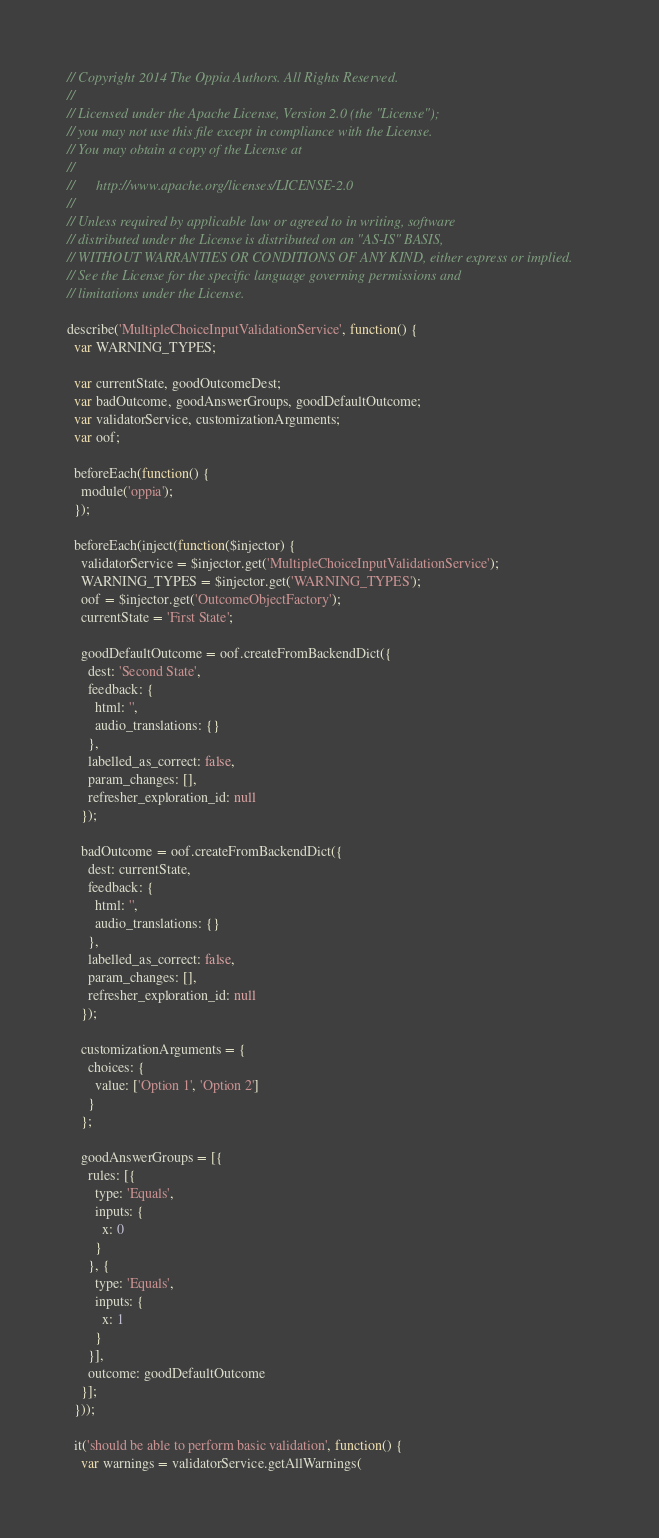<code> <loc_0><loc_0><loc_500><loc_500><_JavaScript_>// Copyright 2014 The Oppia Authors. All Rights Reserved.
//
// Licensed under the Apache License, Version 2.0 (the "License");
// you may not use this file except in compliance with the License.
// You may obtain a copy of the License at
//
//      http://www.apache.org/licenses/LICENSE-2.0
//
// Unless required by applicable law or agreed to in writing, software
// distributed under the License is distributed on an "AS-IS" BASIS,
// WITHOUT WARRANTIES OR CONDITIONS OF ANY KIND, either express or implied.
// See the License for the specific language governing permissions and
// limitations under the License.

describe('MultipleChoiceInputValidationService', function() {
  var WARNING_TYPES;

  var currentState, goodOutcomeDest;
  var badOutcome, goodAnswerGroups, goodDefaultOutcome;
  var validatorService, customizationArguments;
  var oof;

  beforeEach(function() {
    module('oppia');
  });

  beforeEach(inject(function($injector) {
    validatorService = $injector.get('MultipleChoiceInputValidationService');
    WARNING_TYPES = $injector.get('WARNING_TYPES');
    oof = $injector.get('OutcomeObjectFactory');
    currentState = 'First State';

    goodDefaultOutcome = oof.createFromBackendDict({
      dest: 'Second State',
      feedback: {
        html: '',
        audio_translations: {}
      },
      labelled_as_correct: false,
      param_changes: [],
      refresher_exploration_id: null
    });

    badOutcome = oof.createFromBackendDict({
      dest: currentState,
      feedback: {
        html: '',
        audio_translations: {}
      },
      labelled_as_correct: false,
      param_changes: [],
      refresher_exploration_id: null
    });

    customizationArguments = {
      choices: {
        value: ['Option 1', 'Option 2']
      }
    };

    goodAnswerGroups = [{
      rules: [{
        type: 'Equals',
        inputs: {
          x: 0
        }
      }, {
        type: 'Equals',
        inputs: {
          x: 1
        }
      }],
      outcome: goodDefaultOutcome
    }];
  }));

  it('should be able to perform basic validation', function() {
    var warnings = validatorService.getAllWarnings(</code> 